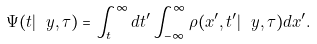<formula> <loc_0><loc_0><loc_500><loc_500>\Psi ( t | \ y , \tau ) = \int _ { t } ^ { \infty } d t ^ { \prime } \int _ { - \infty } ^ { \infty } \rho ( x ^ { \prime } , t ^ { \prime } | \ y , \tau ) d x ^ { \prime } .</formula> 